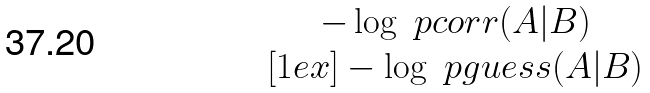<formula> <loc_0><loc_0><loc_500><loc_500>\begin{matrix} - \log \ p c o r r ( A | B ) \\ [ 1 e x ] - \log \ p g u e s s ( A | B ) \end{matrix}</formula> 